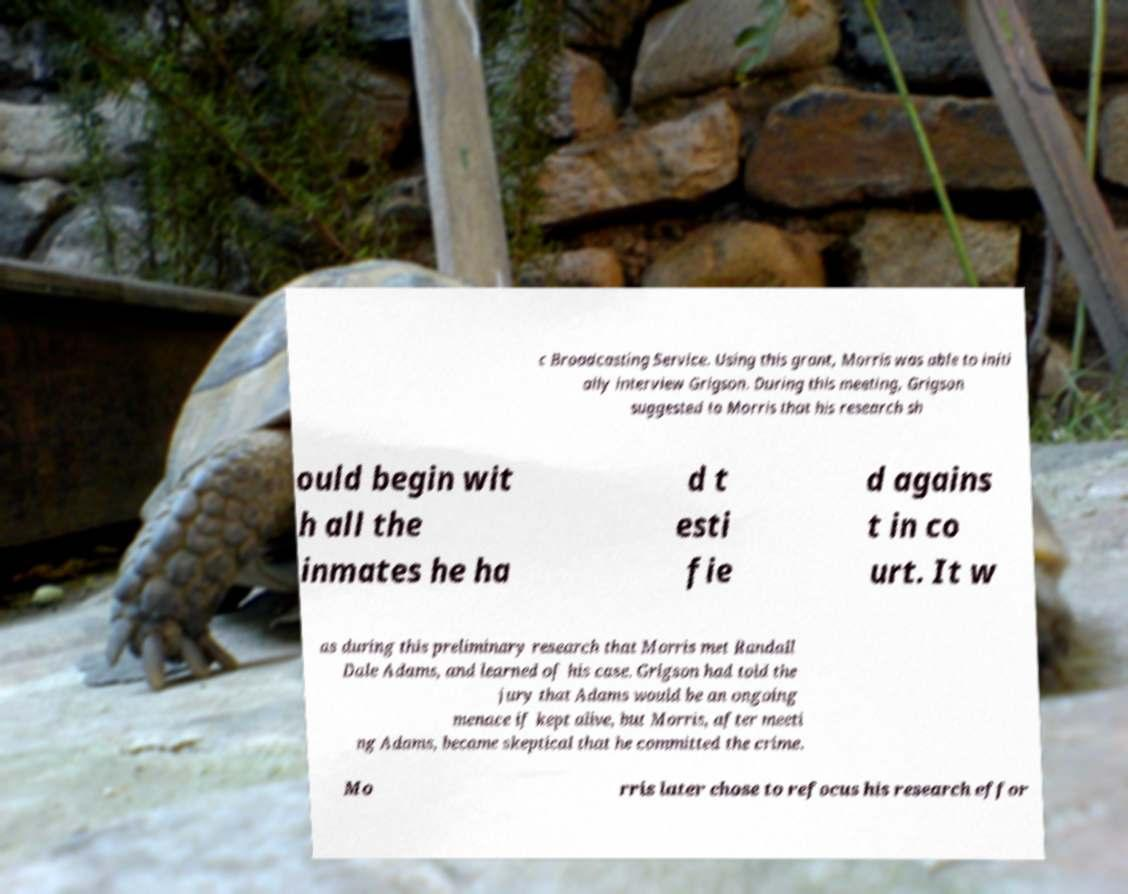Please read and relay the text visible in this image. What does it say? c Broadcasting Service. Using this grant, Morris was able to initi ally interview Grigson. During this meeting, Grigson suggested to Morris that his research sh ould begin wit h all the inmates he ha d t esti fie d agains t in co urt. It w as during this preliminary research that Morris met Randall Dale Adams, and learned of his case. Grigson had told the jury that Adams would be an ongoing menace if kept alive, but Morris, after meeti ng Adams, became skeptical that he committed the crime. Mo rris later chose to refocus his research effor 